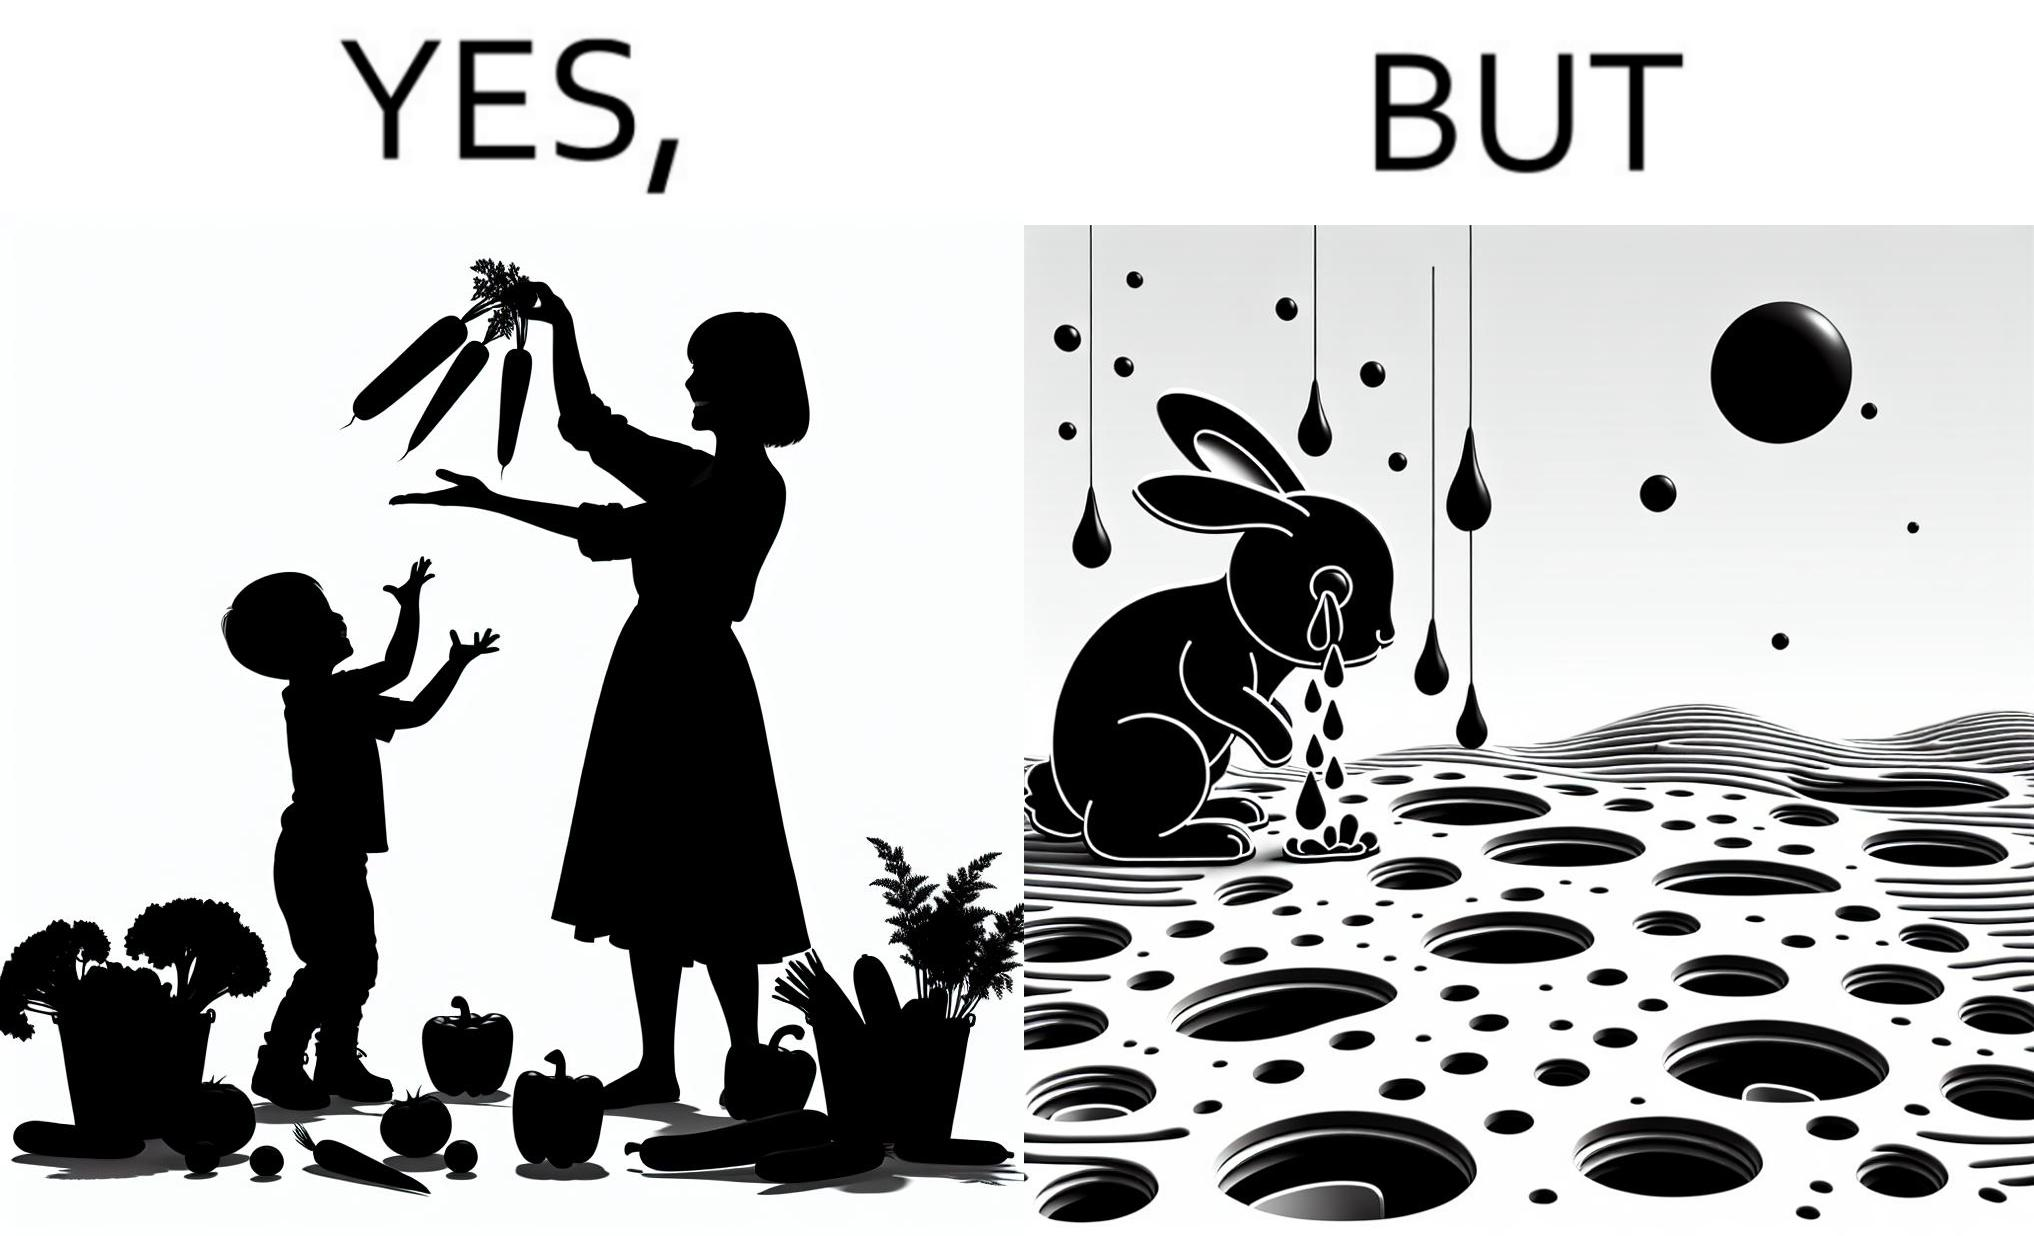Describe the contrast between the left and right parts of this image. In the left part of the image: It is a woman and child making funny shapes with vegetables and playing with them In the right part of the image: It is rabbit crying in a ground full of holes 